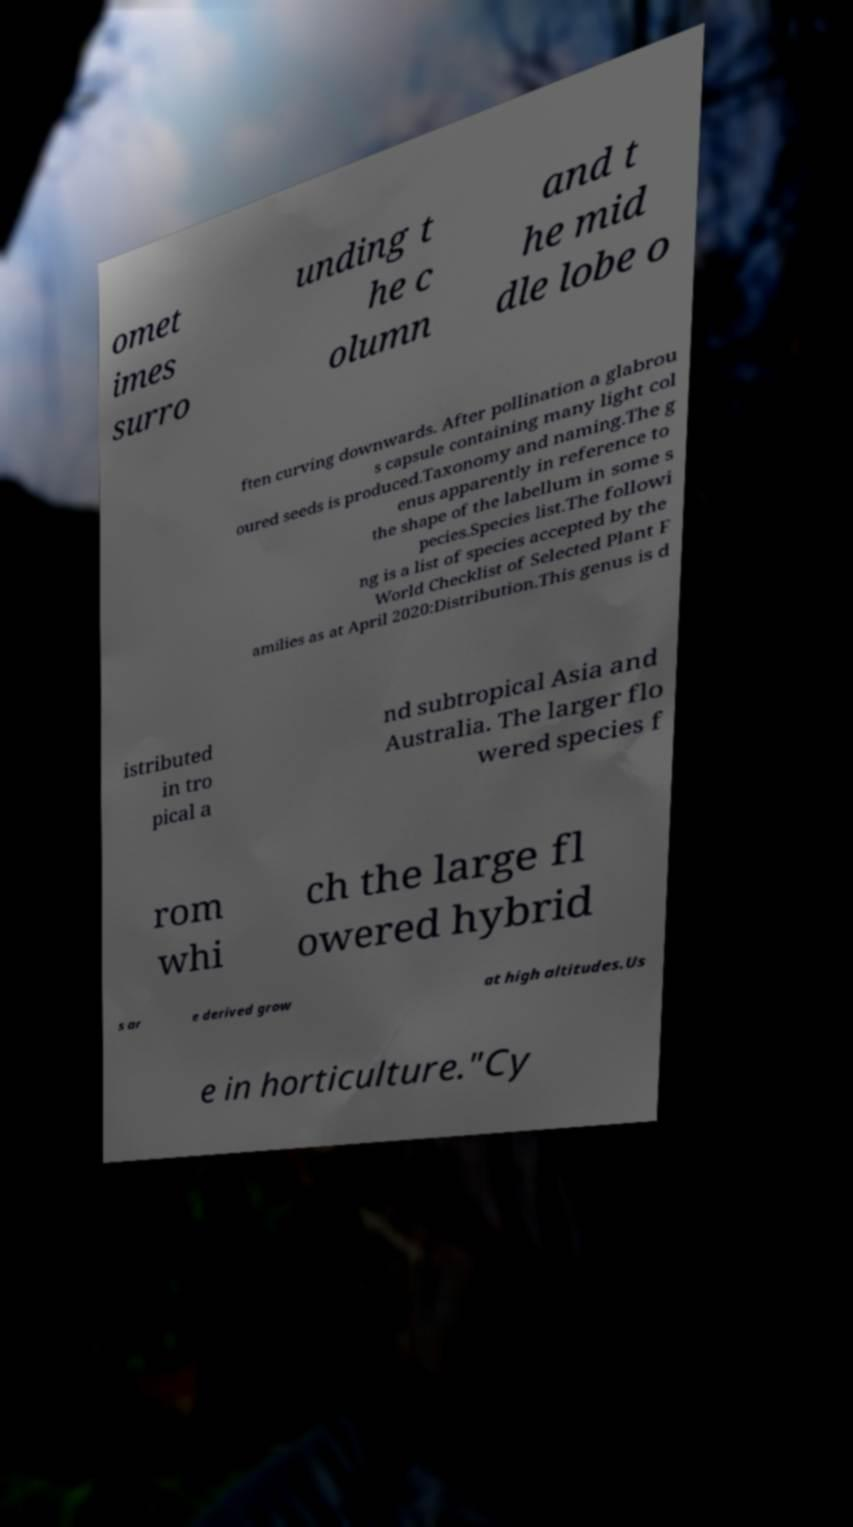Can you read and provide the text displayed in the image?This photo seems to have some interesting text. Can you extract and type it out for me? omet imes surro unding t he c olumn and t he mid dle lobe o ften curving downwards. After pollination a glabrou s capsule containing many light col oured seeds is produced.Taxonomy and naming.The g enus apparently in reference to the shape of the labellum in some s pecies.Species list.The followi ng is a list of species accepted by the World Checklist of Selected Plant F amilies as at April 2020:Distribution.This genus is d istributed in tro pical a nd subtropical Asia and Australia. The larger flo wered species f rom whi ch the large fl owered hybrid s ar e derived grow at high altitudes.Us e in horticulture."Cy 